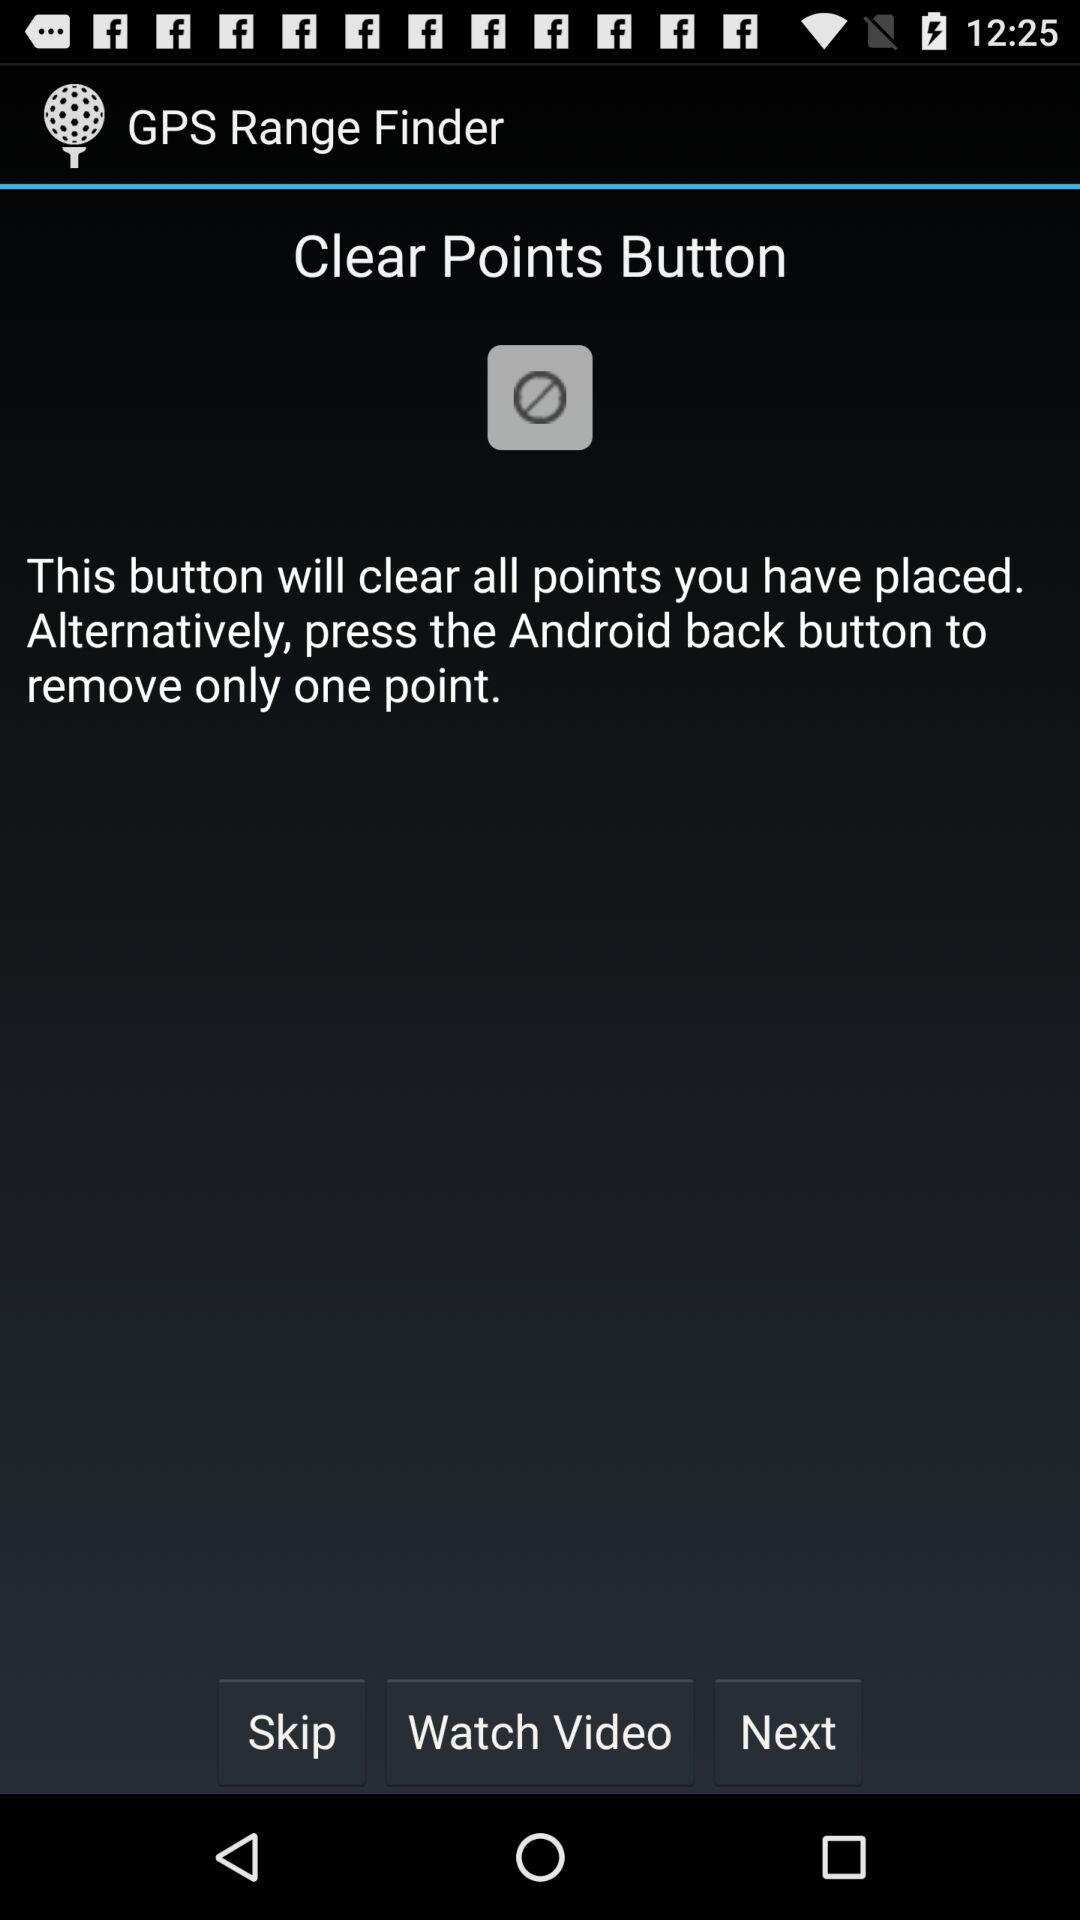What is the application name? The application name is "GPS Range Finder". 